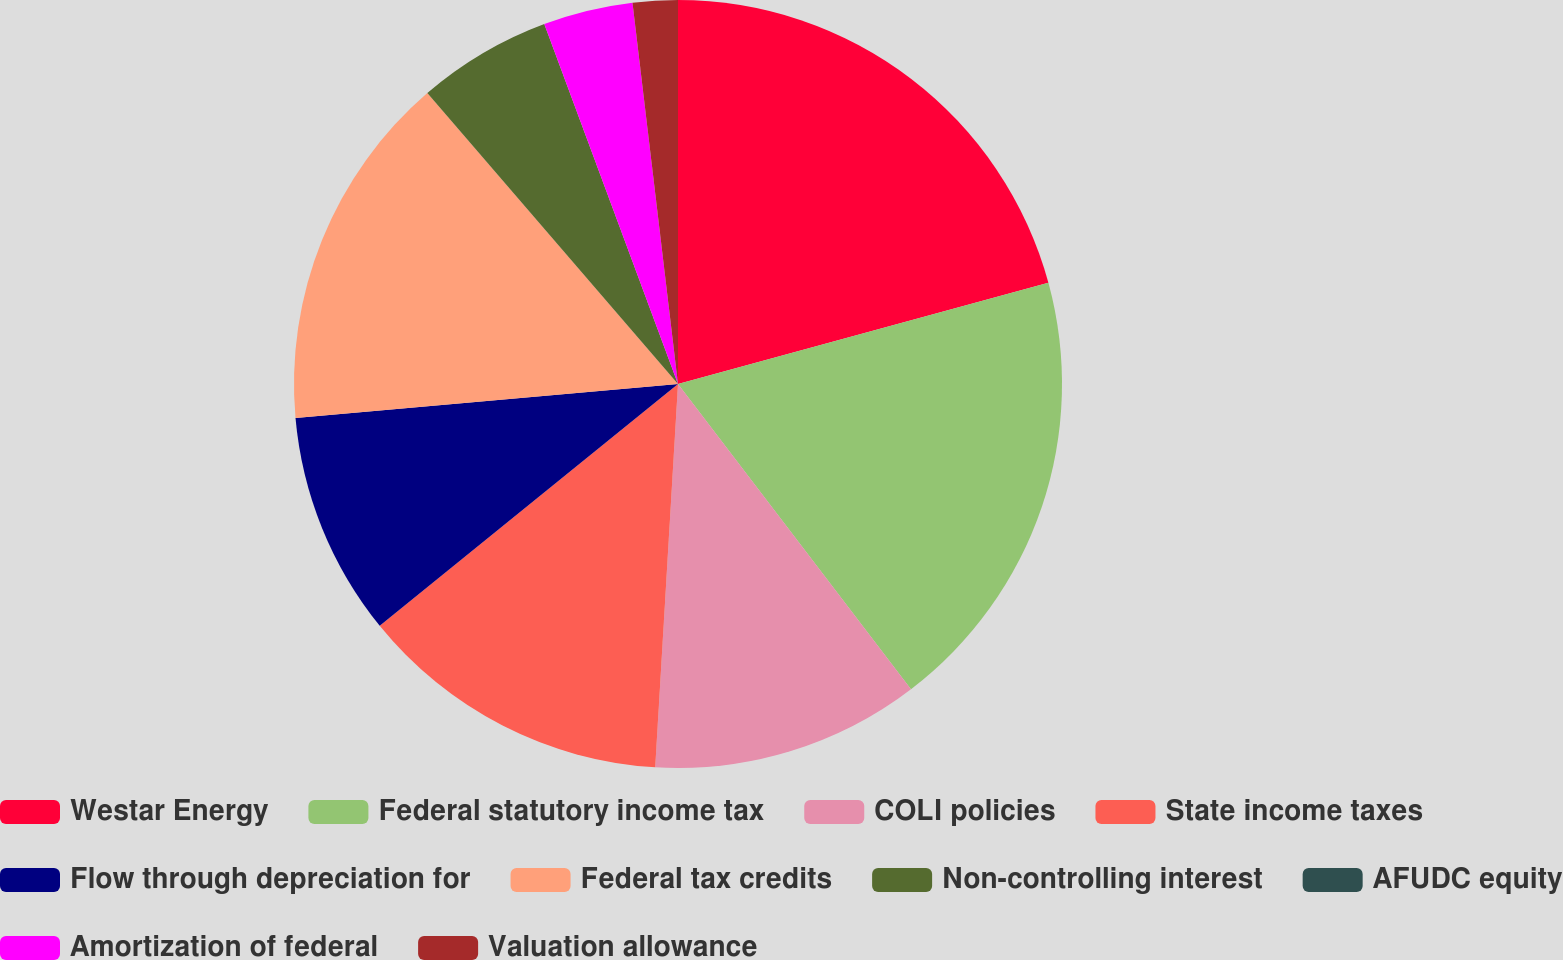Convert chart to OTSL. <chart><loc_0><loc_0><loc_500><loc_500><pie_chart><fcel>Westar Energy<fcel>Federal statutory income tax<fcel>COLI policies<fcel>State income taxes<fcel>Flow through depreciation for<fcel>Federal tax credits<fcel>Non-controlling interest<fcel>AFUDC equity<fcel>Amortization of federal<fcel>Valuation allowance<nl><fcel>20.75%<fcel>18.87%<fcel>11.32%<fcel>13.21%<fcel>9.43%<fcel>15.09%<fcel>5.66%<fcel>0.0%<fcel>3.77%<fcel>1.89%<nl></chart> 